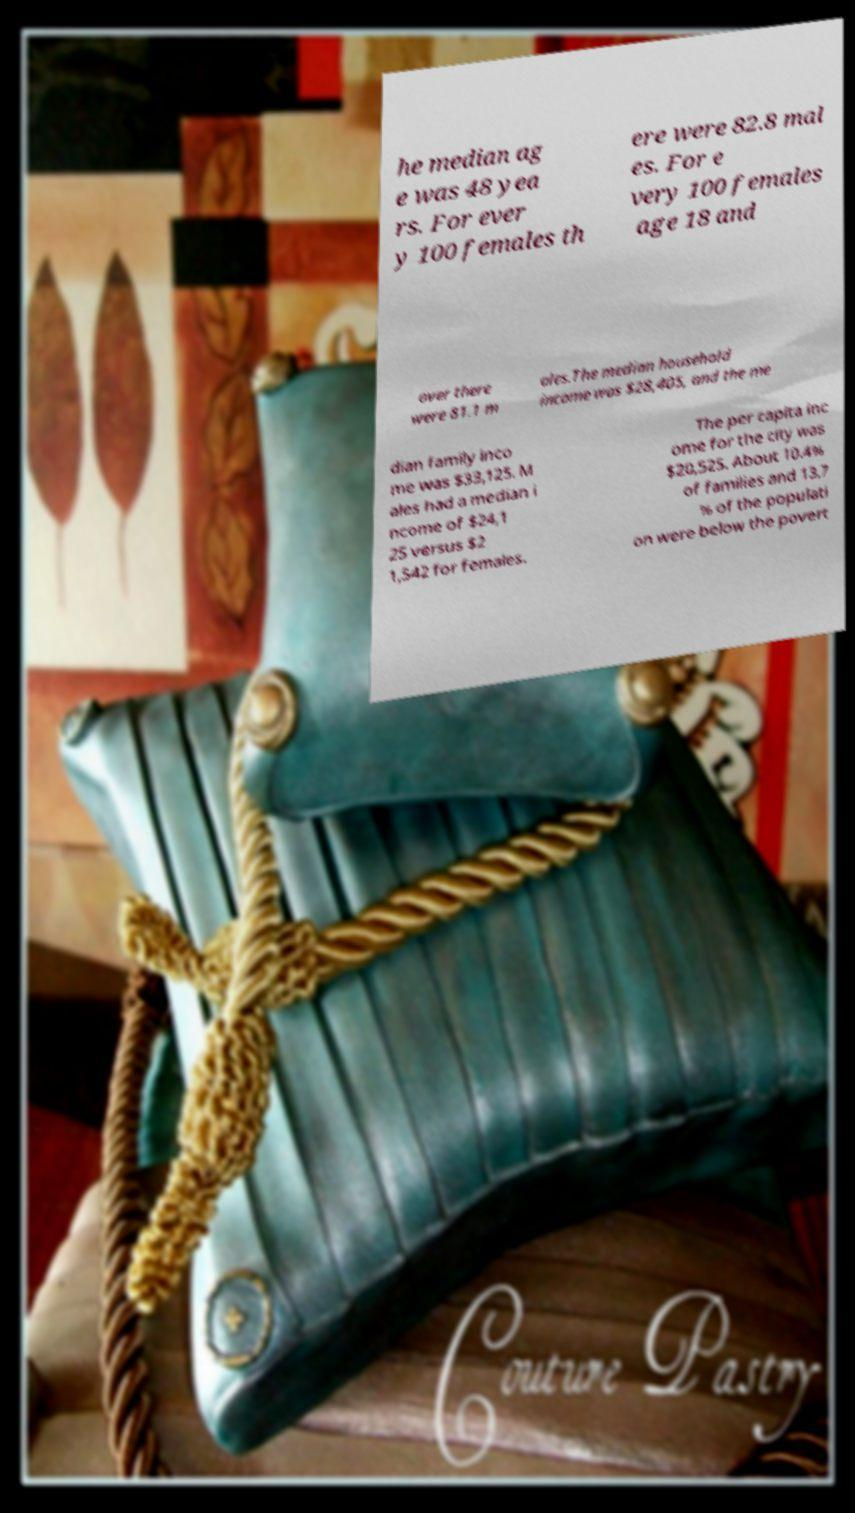I need the written content from this picture converted into text. Can you do that? he median ag e was 48 yea rs. For ever y 100 females th ere were 82.8 mal es. For e very 100 females age 18 and over there were 81.1 m ales.The median household income was $28,405, and the me dian family inco me was $33,125. M ales had a median i ncome of $24,1 25 versus $2 1,542 for females. The per capita inc ome for the city was $20,525. About 10.4% of families and 13.7 % of the populati on were below the povert 